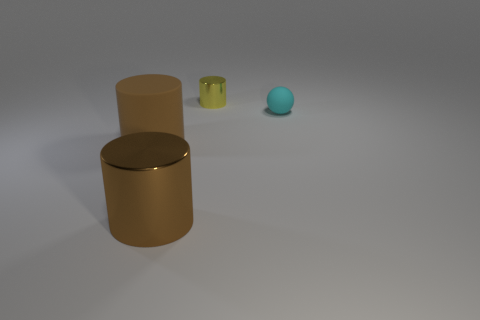Add 1 red matte cylinders. How many objects exist? 5 Subtract all balls. How many objects are left? 3 Add 1 tiny yellow cylinders. How many tiny yellow cylinders are left? 2 Add 2 big gray matte cylinders. How many big gray matte cylinders exist? 2 Subtract 0 blue spheres. How many objects are left? 4 Subtract all cyan balls. Subtract all small matte balls. How many objects are left? 2 